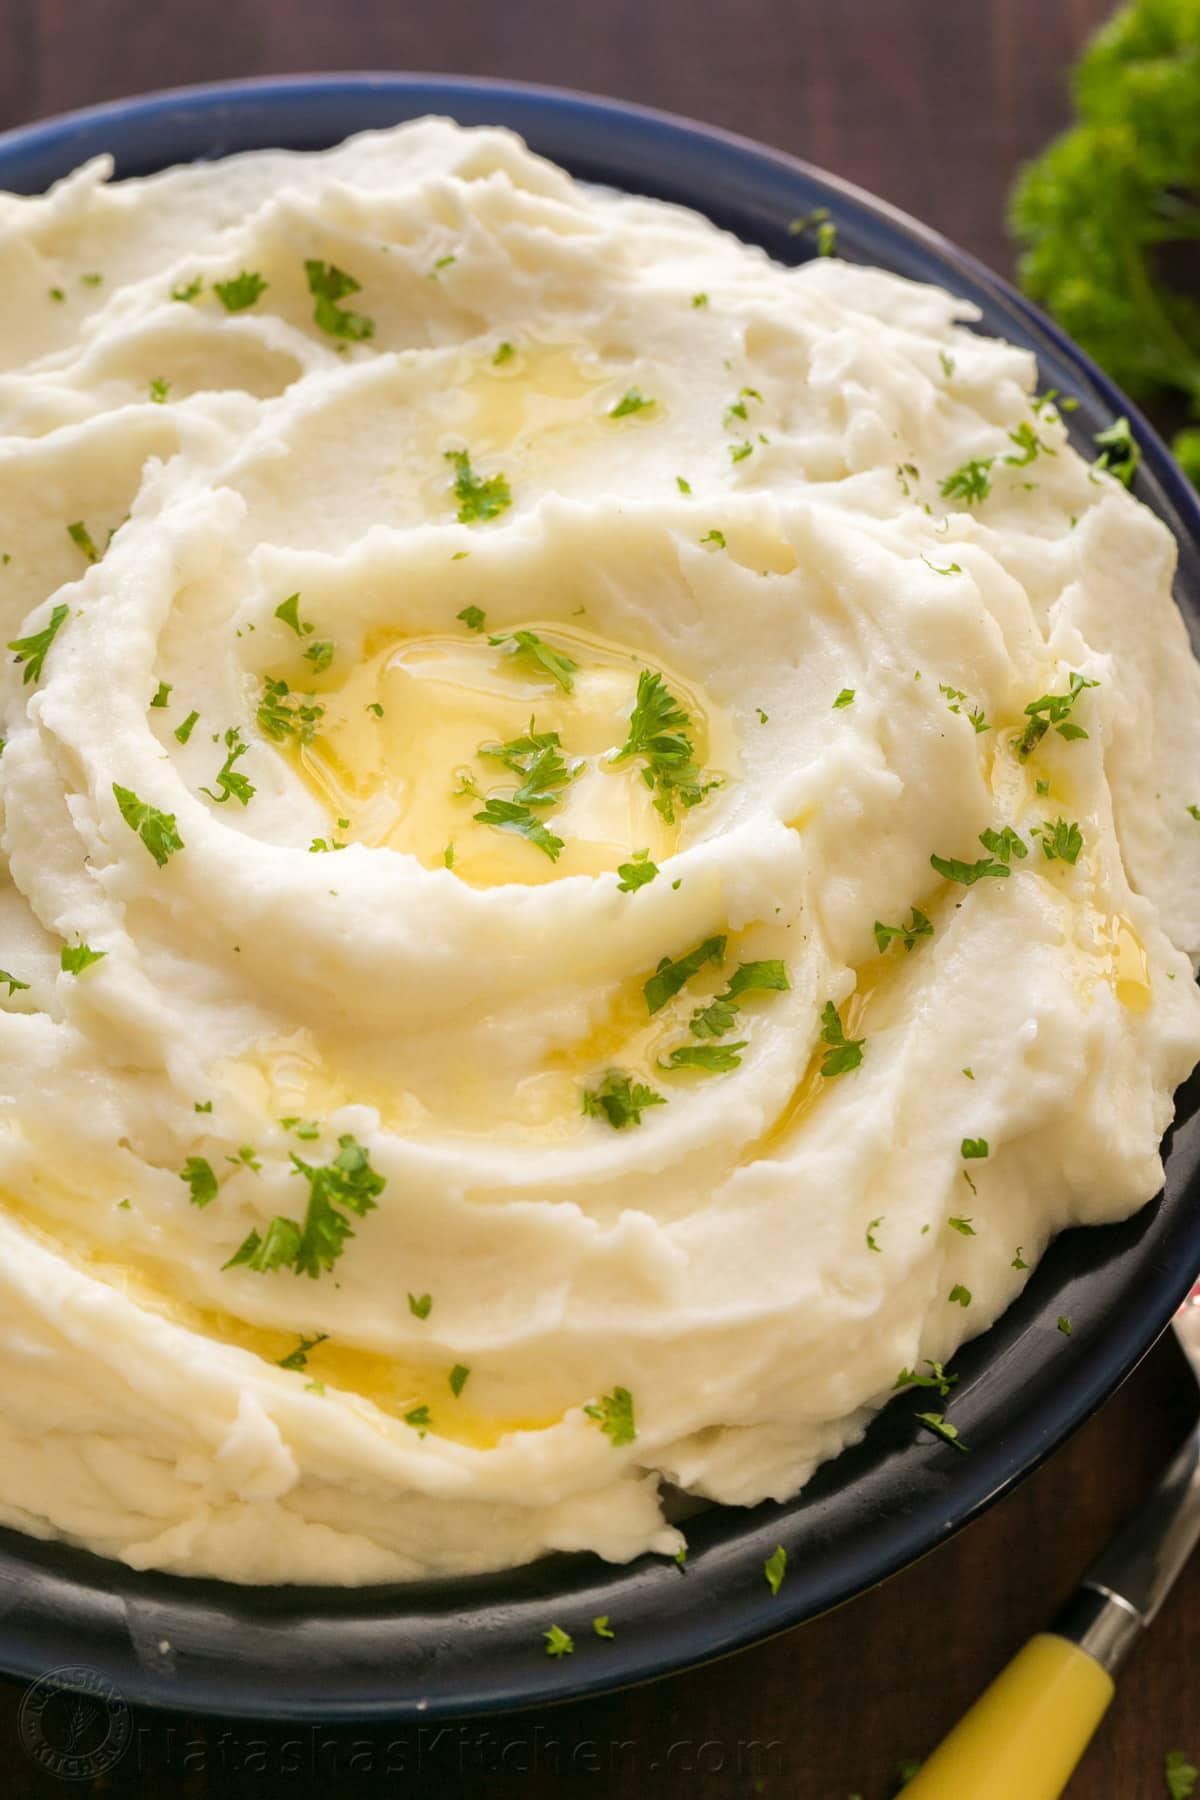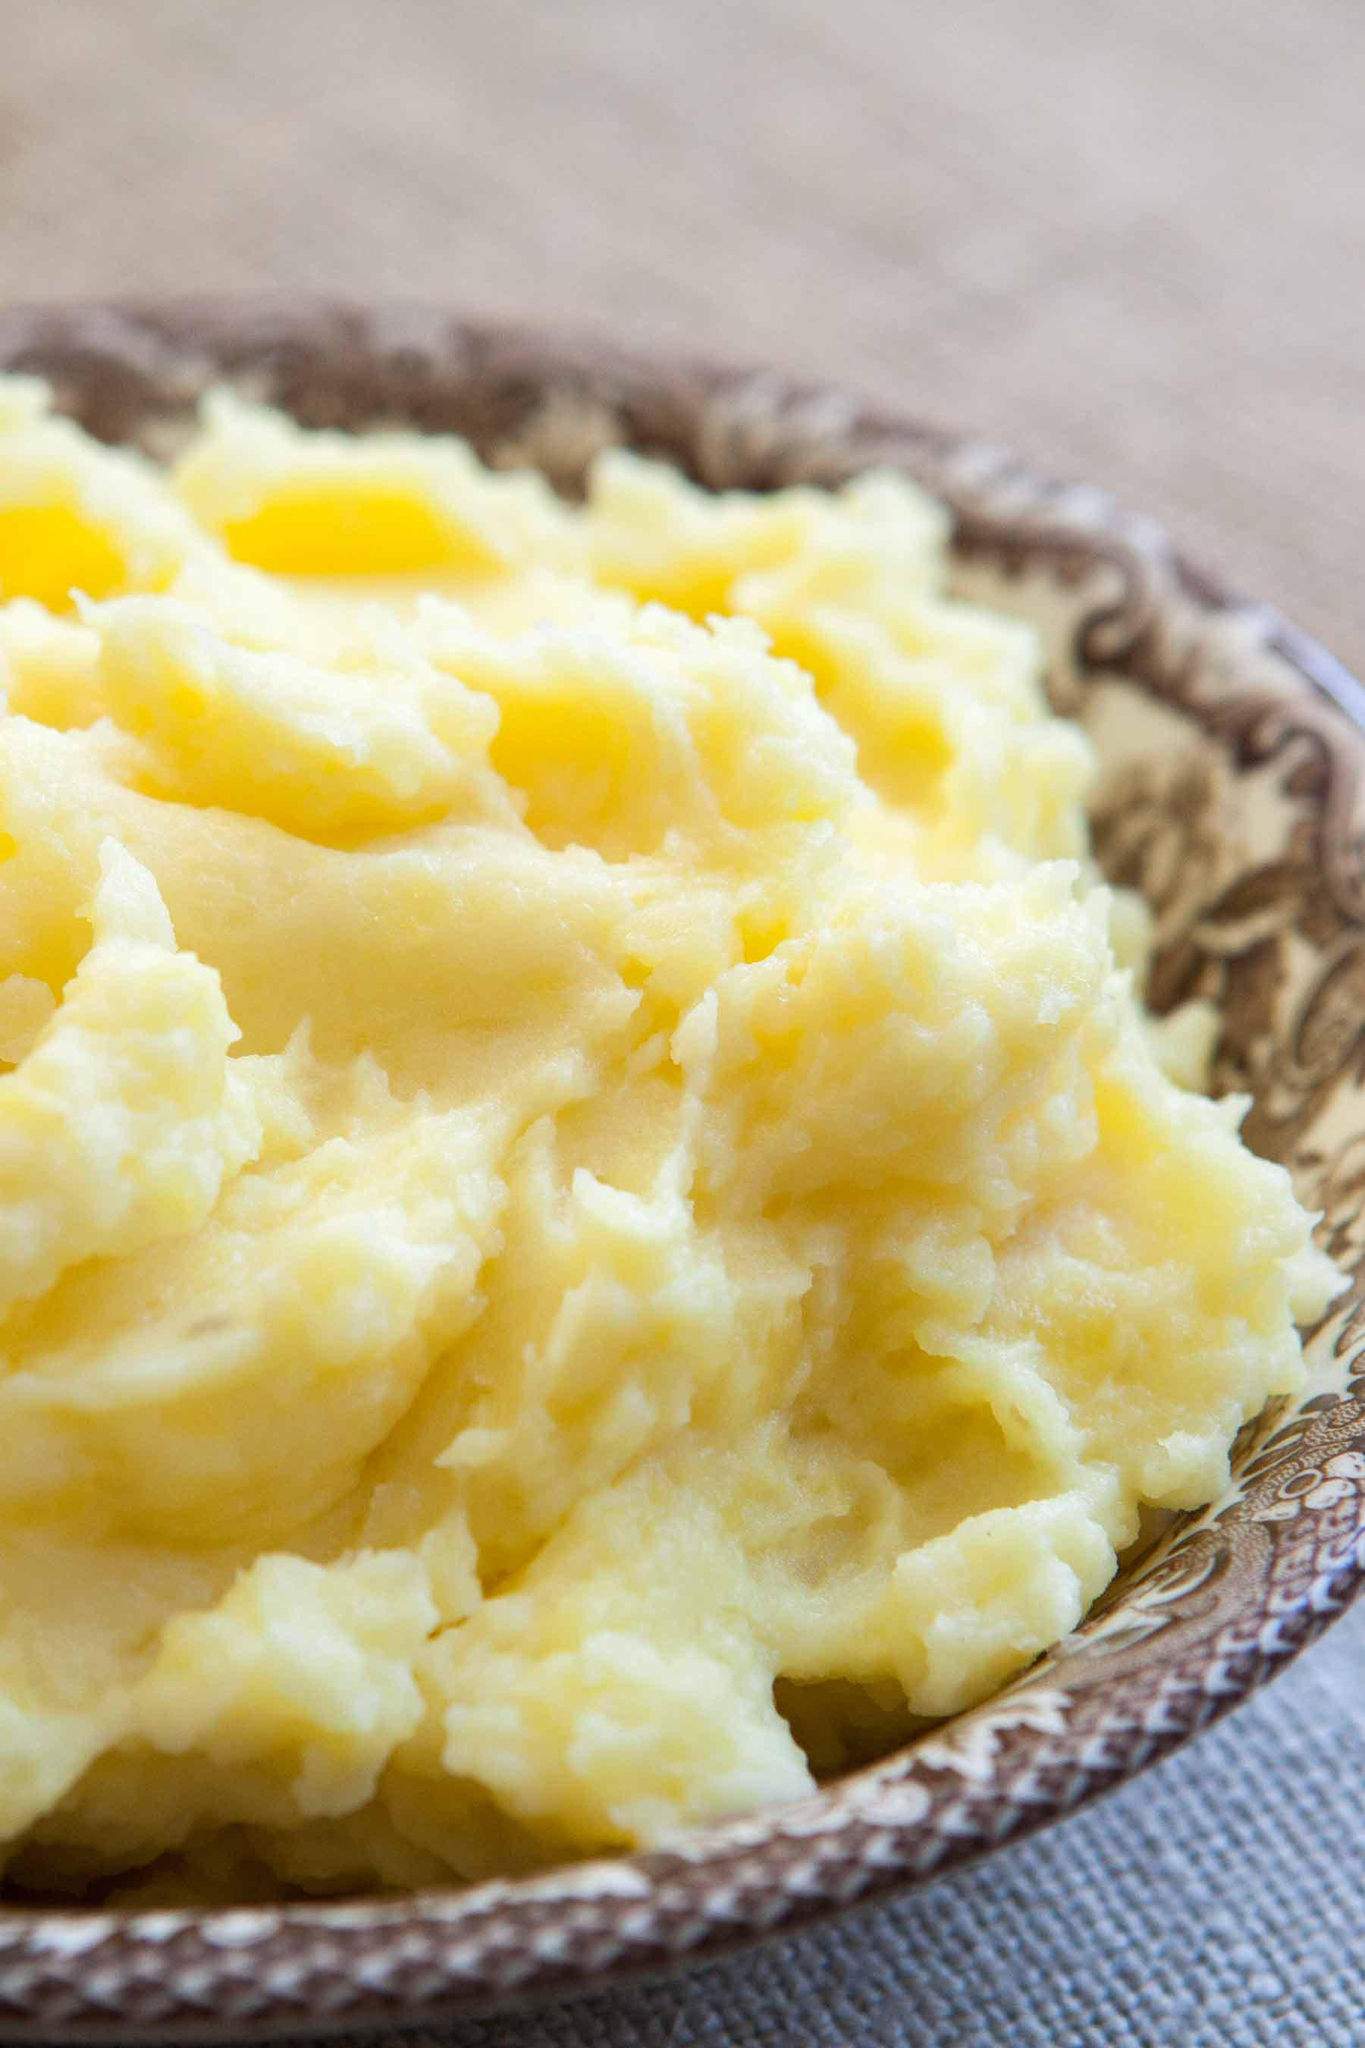The first image is the image on the left, the second image is the image on the right. Examine the images to the left and right. Is the description "The left and right image contains the same number of mash potatoes and chive bowls." accurate? Answer yes or no. No. 